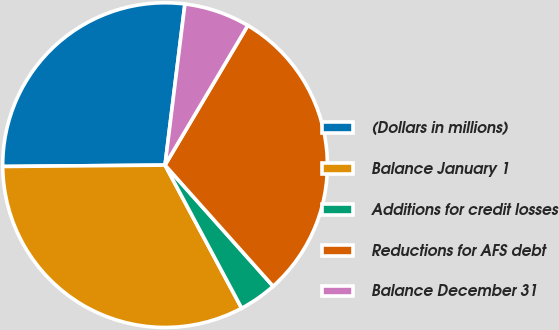Convert chart. <chart><loc_0><loc_0><loc_500><loc_500><pie_chart><fcel>(Dollars in millions)<fcel>Balance January 1<fcel>Additions for credit losses<fcel>Reductions for AFS debt<fcel>Balance December 31<nl><fcel>27.09%<fcel>32.69%<fcel>3.77%<fcel>29.89%<fcel>6.56%<nl></chart> 